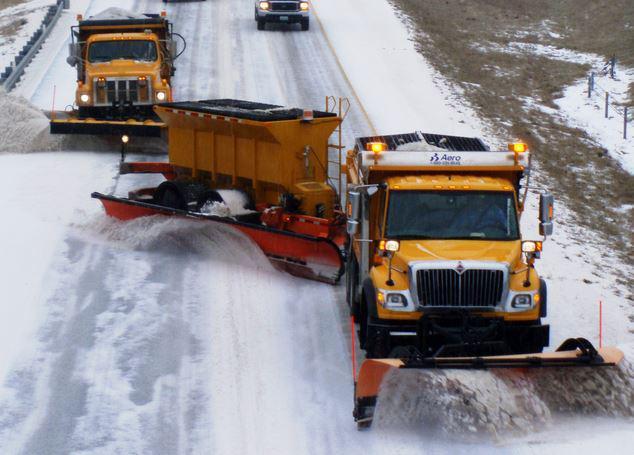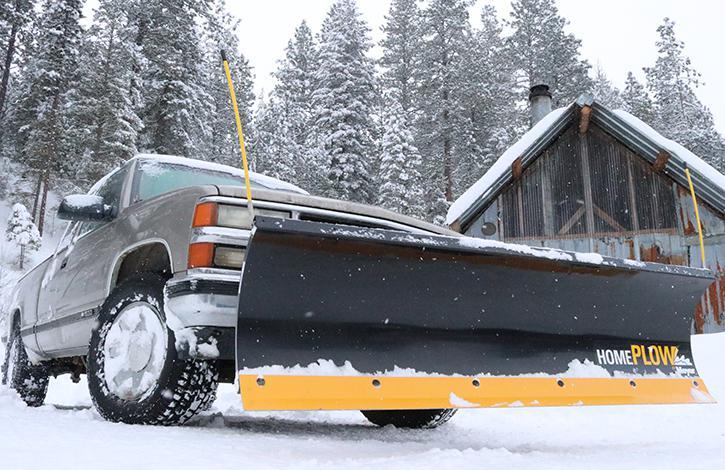The first image is the image on the left, the second image is the image on the right. Considering the images on both sides, is "The left and right image contains a total of three snow trucks." valid? Answer yes or no. Yes. 